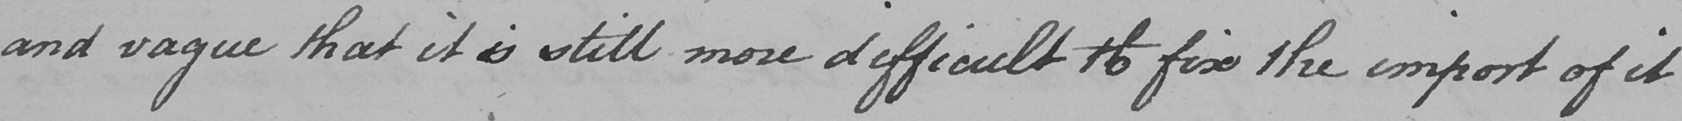Please provide the text content of this handwritten line. and vague that it is still more difficult to fix the import of it 